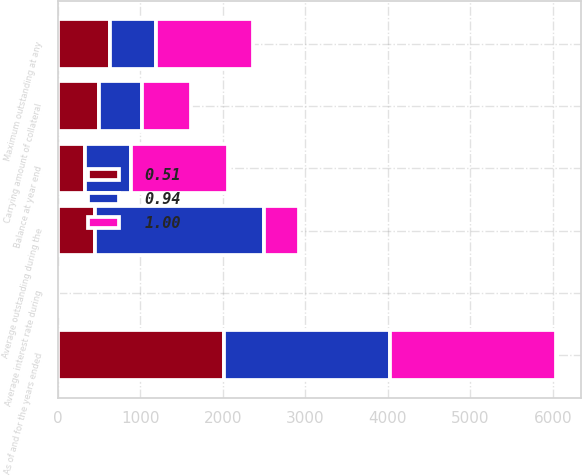Convert chart to OTSL. <chart><loc_0><loc_0><loc_500><loc_500><stacked_bar_chart><ecel><fcel>As of and for the years ended<fcel>Balance at year end<fcel>Average outstanding during the<fcel>Maximum outstanding at any<fcel>Average interest rate during<fcel>Carrying amount of collateral<nl><fcel>0.94<fcel>2013<fcel>555.55<fcel>2043.9<fcel>555.55<fcel>0.4<fcel>511.2<nl><fcel>1<fcel>2012<fcel>1178.3<fcel>419.5<fcel>1178.3<fcel>1.23<fcel>599.9<nl><fcel>0.51<fcel>2011<fcel>332.4<fcel>456.1<fcel>631.9<fcel>1.48<fcel>505.7<nl></chart> 